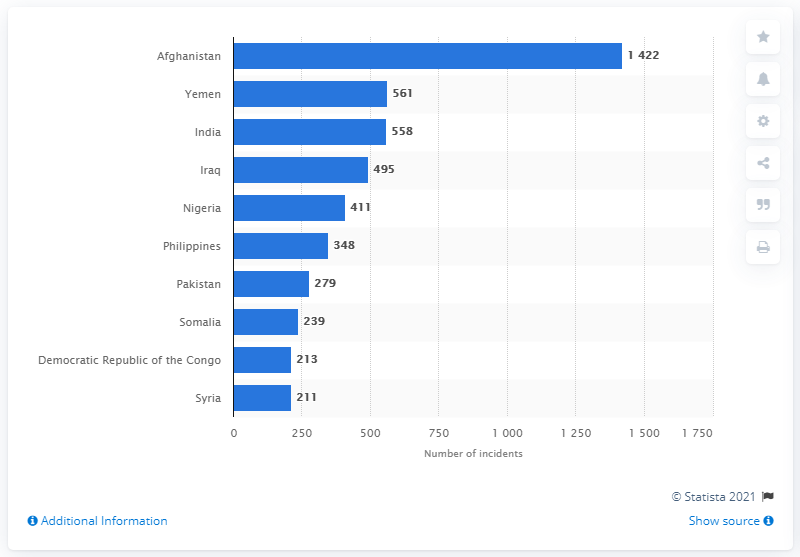Specify some key components in this picture. In 2019, there were 561 reported incidents of terrorism in Yemen. In 2019, there were 558 reported terrorist incidents in India. 